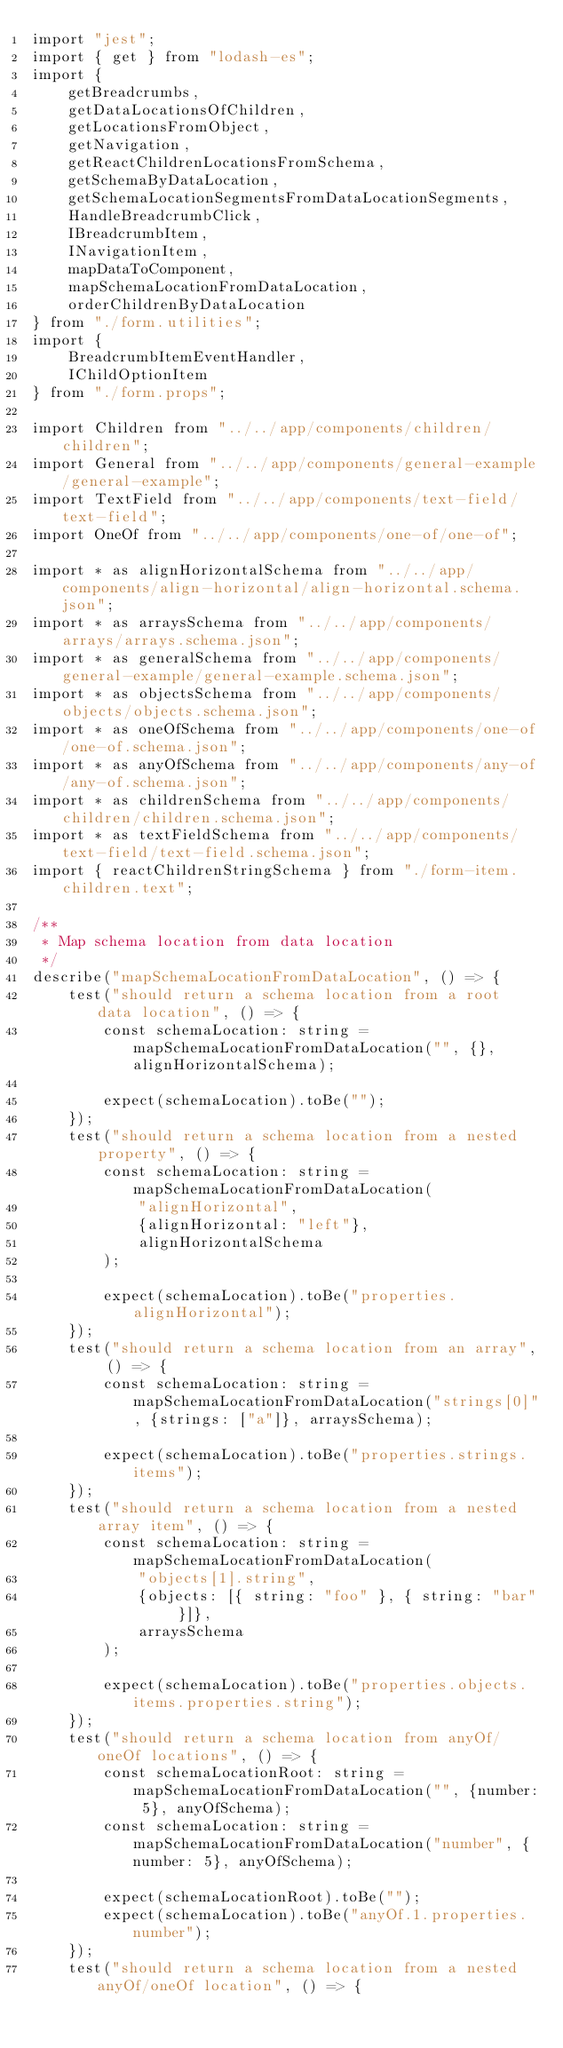<code> <loc_0><loc_0><loc_500><loc_500><_TypeScript_>import "jest";
import { get } from "lodash-es";
import {
    getBreadcrumbs,
    getDataLocationsOfChildren,
    getLocationsFromObject,
    getNavigation,
    getReactChildrenLocationsFromSchema,
    getSchemaByDataLocation,
    getSchemaLocationSegmentsFromDataLocationSegments,
    HandleBreadcrumbClick,
    IBreadcrumbItem,
    INavigationItem,
    mapDataToComponent,
    mapSchemaLocationFromDataLocation,
    orderChildrenByDataLocation
} from "./form.utilities";
import {
    BreadcrumbItemEventHandler,
    IChildOptionItem
} from "./form.props";

import Children from "../../app/components/children/children";
import General from "../../app/components/general-example/general-example";
import TextField from "../../app/components/text-field/text-field";
import OneOf from "../../app/components/one-of/one-of";

import * as alignHorizontalSchema from "../../app/components/align-horizontal/align-horizontal.schema.json";
import * as arraysSchema from "../../app/components/arrays/arrays.schema.json";
import * as generalSchema from "../../app/components/general-example/general-example.schema.json";
import * as objectsSchema from "../../app/components/objects/objects.schema.json";
import * as oneOfSchema from "../../app/components/one-of/one-of.schema.json";
import * as anyOfSchema from "../../app/components/any-of/any-of.schema.json";
import * as childrenSchema from "../../app/components/children/children.schema.json";
import * as textFieldSchema from "../../app/components/text-field/text-field.schema.json";
import { reactChildrenStringSchema } from "./form-item.children.text";

/**
 * Map schema location from data location
 */
describe("mapSchemaLocationFromDataLocation", () => {
    test("should return a schema location from a root data location", () => {
        const schemaLocation: string = mapSchemaLocationFromDataLocation("", {}, alignHorizontalSchema);

        expect(schemaLocation).toBe("");
    });
    test("should return a schema location from a nested property", () => {
        const schemaLocation: string = mapSchemaLocationFromDataLocation(
            "alignHorizontal",
            {alignHorizontal: "left"},
            alignHorizontalSchema
        );

        expect(schemaLocation).toBe("properties.alignHorizontal");
    });
    test("should return a schema location from an array", () => {
        const schemaLocation: string = mapSchemaLocationFromDataLocation("strings[0]", {strings: ["a"]}, arraysSchema);

        expect(schemaLocation).toBe("properties.strings.items");
    });
    test("should return a schema location from a nested array item", () => {
        const schemaLocation: string = mapSchemaLocationFromDataLocation(
            "objects[1].string",
            {objects: [{ string: "foo" }, { string: "bar" }]},
            arraysSchema
        );

        expect(schemaLocation).toBe("properties.objects.items.properties.string");
    });
    test("should return a schema location from anyOf/oneOf locations", () => {
        const schemaLocationRoot: string = mapSchemaLocationFromDataLocation("", {number: 5}, anyOfSchema);
        const schemaLocation: string = mapSchemaLocationFromDataLocation("number", {number: 5}, anyOfSchema);

        expect(schemaLocationRoot).toBe("");
        expect(schemaLocation).toBe("anyOf.1.properties.number");
    });
    test("should return a schema location from a nested anyOf/oneOf location", () => {</code> 